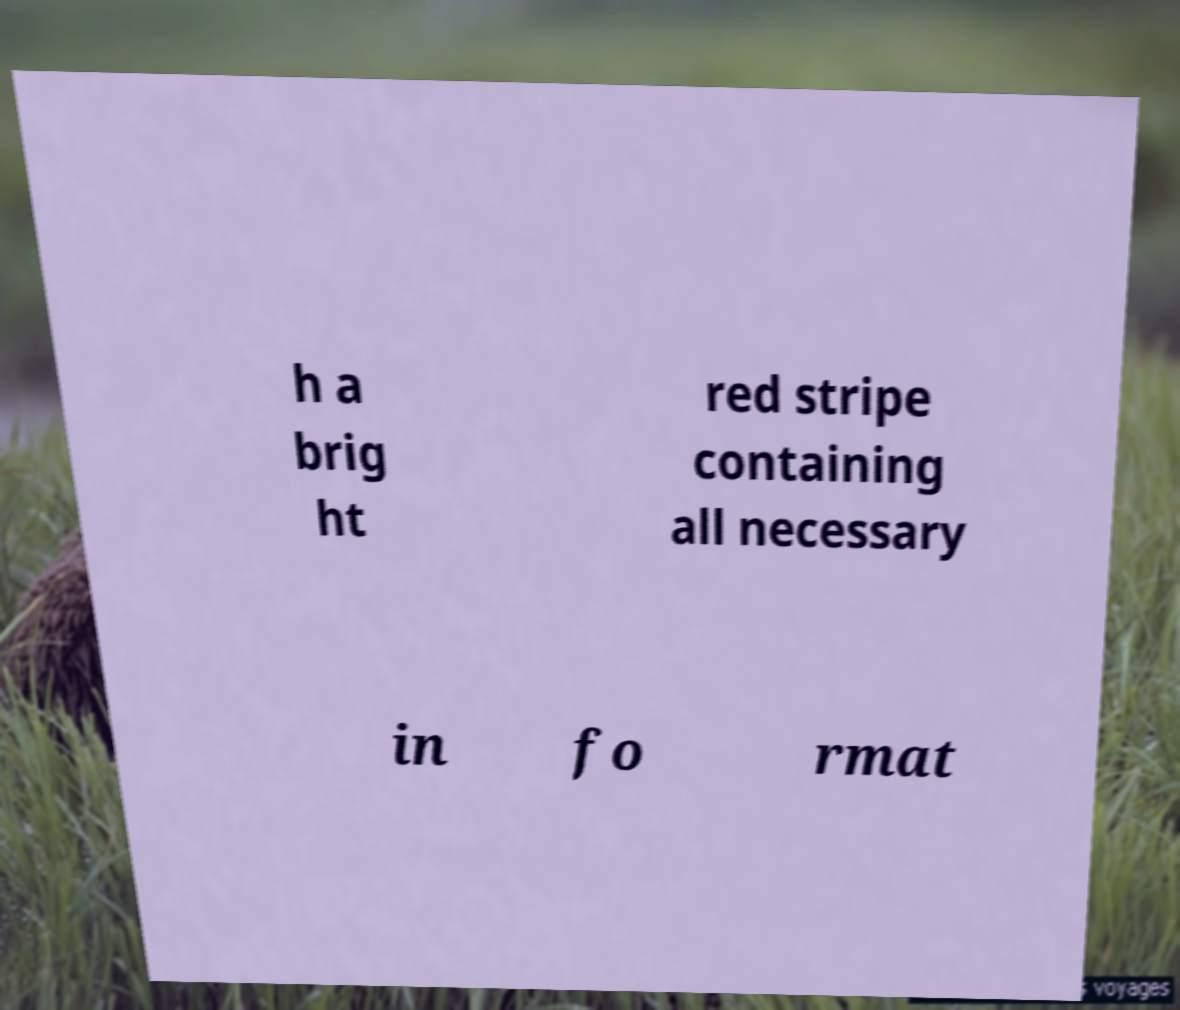Can you read and provide the text displayed in the image?This photo seems to have some interesting text. Can you extract and type it out for me? h a brig ht red stripe containing all necessary in fo rmat 